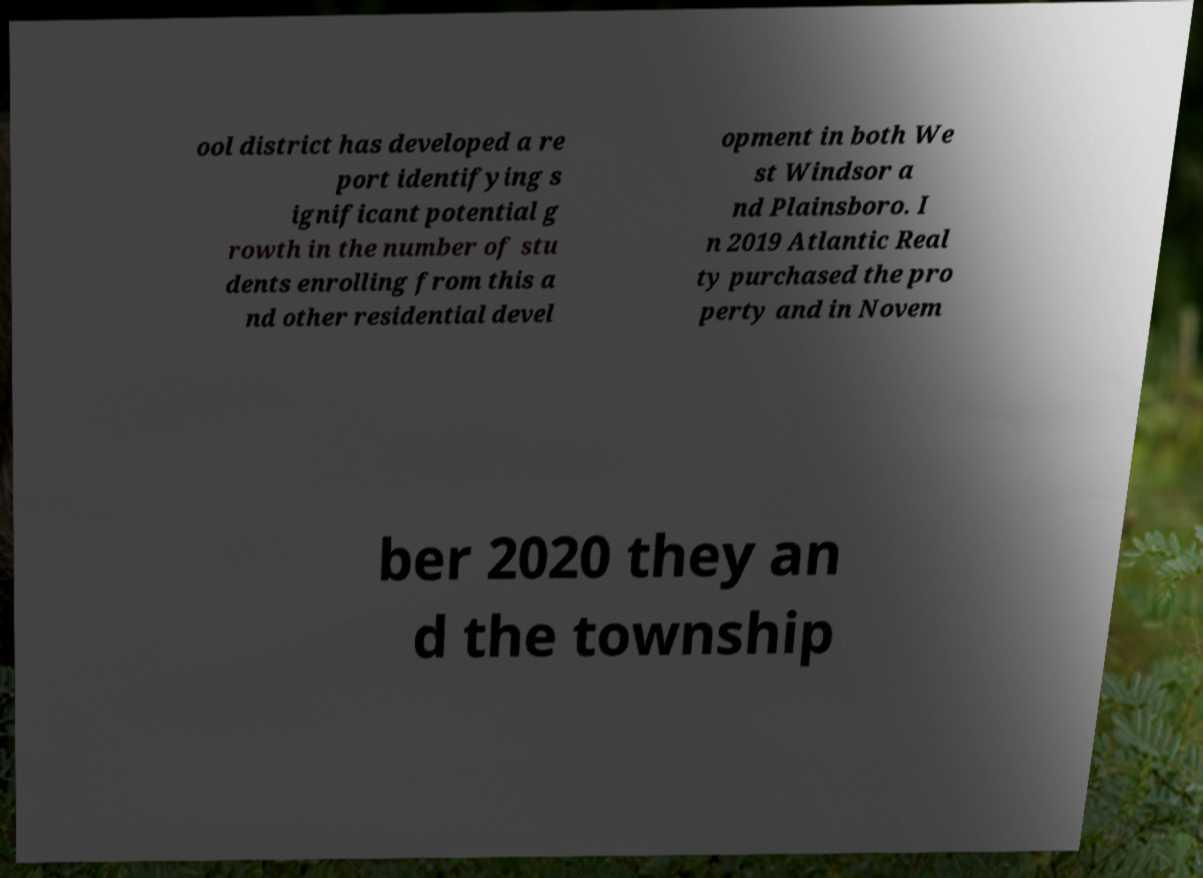Please read and relay the text visible in this image. What does it say? ool district has developed a re port identifying s ignificant potential g rowth in the number of stu dents enrolling from this a nd other residential devel opment in both We st Windsor a nd Plainsboro. I n 2019 Atlantic Real ty purchased the pro perty and in Novem ber 2020 they an d the township 